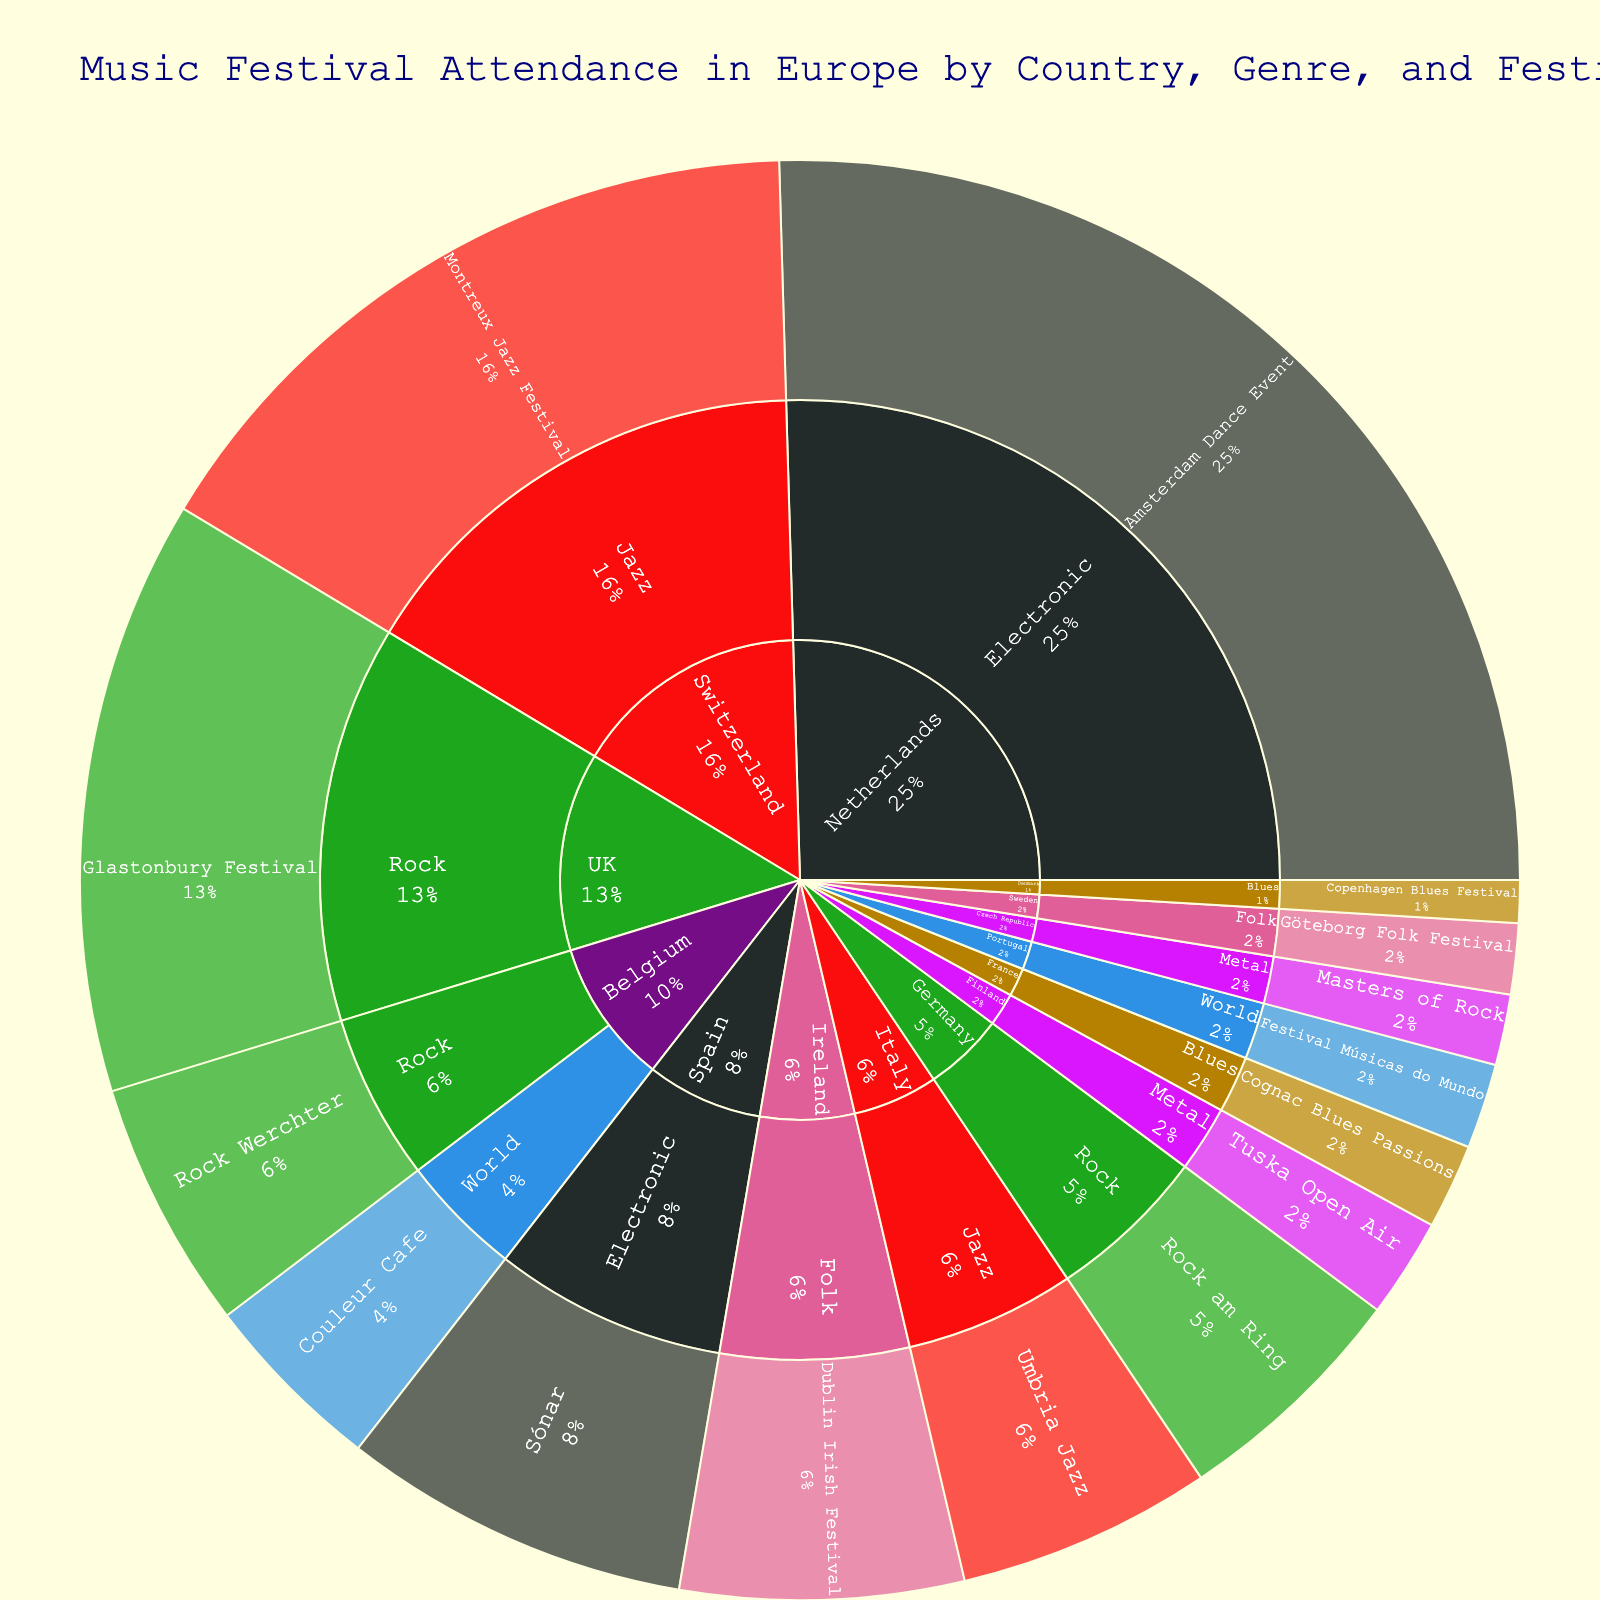What's the title of this figure? The title can be found at the top of the figure, designed to provide a brief description of the visualized data.
Answer: Music Festival Attendance in Europe by Country, Genre, and Festival Which country has the highest music festival attendance? To find this, identify the part of the sunburst representing the country with the largest section.
Answer: Netherlands What is the attendance of the festival with the lowest count in the Metal genre? Look for the Metal section within each country and find the smallest attendance figure.
Answer: 25,000 Compare the total attendance of Rock festivals and Electronic festivals. Sum up the attendance figures for all Rock festivals and do the same for Electronic festivals, then compare the two sums. For Rock: 88,000 + 210,000 + 85,000 = 383,000. For Electronic: 400,000 + 123,000 = 523,000. 523,000 is greater than 383,000.
Answer: Electronic festivals have higher attendance What percentage of the total attendance does the Rock Werchter festival contribute? First, find the total attendance by summing all values. Then, divide the attendance of Rock Werchter by the total and multiply by 100. Total = 88,000 + 210,000 + 85,000 + 30,000 + 15,000 + 400,000 + 123,000 + 250,000 + 90,000 + 100,000 + 25,000 + 65,000 + 30,000 + 35,000 + 25,000 = 1,526,000. Rock Werchter percentage = (88,000 / 1,526,000) * 100.
Answer: 5.76% Which genre has the highest overall attendance? Aggregate the attendance figures for festivals under each genre and compare the sums.
Answer: Electronic How does the attendance of jazz festivals in Switzerland compare to jazz festivals in Italy? Find the attendance numbers for the jazz sections under Switzerland and Italy, then compare them. Switzerland: 250,000; Italy: 90,000. 250,000 is greater than 90,000.
Answer: Switzerland has higher attendance What's the average attendance of Folk festivals? Sum the attendance figures of all Folk festivals and divide by the number of Folk festivals. The sum is 100,000 + 25,000 = 125,000 and the number of Folk festivals is 2. So, the average is 125,000/2.
Answer: 62,500 Which festival has the highest attendance? Look for the largest individual section in the sunburst plot.
Answer: Amsterdam Dance Event How does the attendance of the largest Blues festival compare to the largest World festival? Identify the largest festivals in each genre (Blues and World) and compare their attendance figures. Cognac Blues Passions: 30,000; Couleur Cafe: 65,000. 65,000 is greater than 30,000.
Answer: The largest World festival has higher attendance 